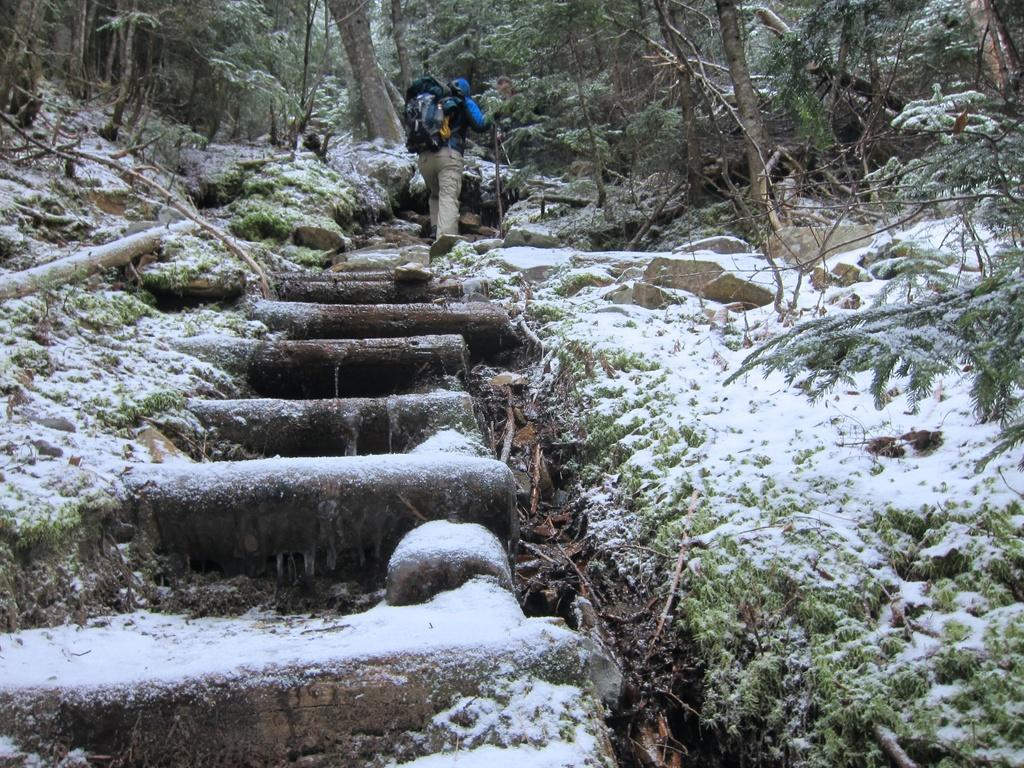Who is present in the image? There is a person in the image. What is the person carrying on their back? The person is wearing a backpack. Where is the person located in the image? The person is walking on a staircase. What type of vegetation can be seen in the image? There are trees and grass in the image. What type of ground surface is present in the image? There are stones in the image. What is the weather like in the image? There is snow in the image. What month is it in the image? The month cannot be determined from the image, as there is no information about the date or time of year. What type of drum can be seen in the image? There is no drum present in the image. 